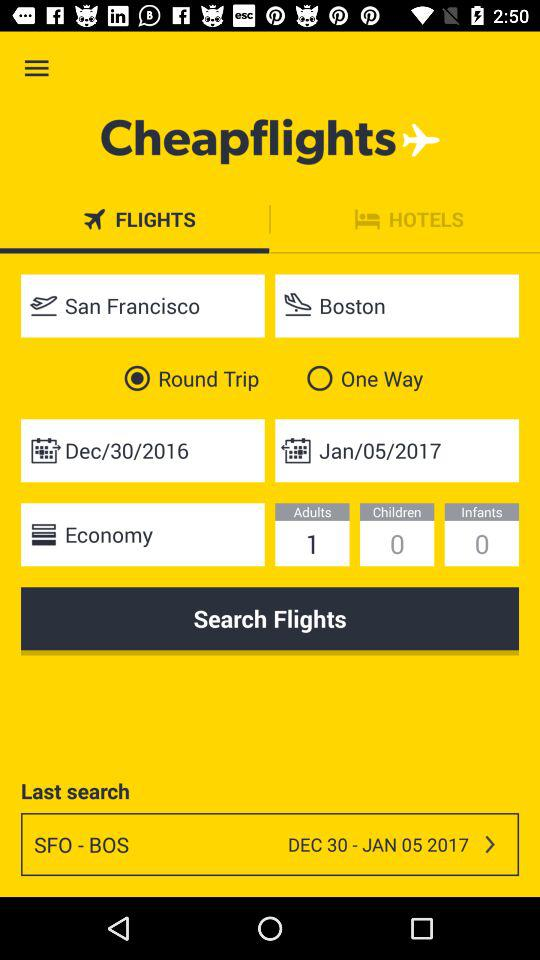What is the selected class for the trip? The selected class for the trip is economy. 